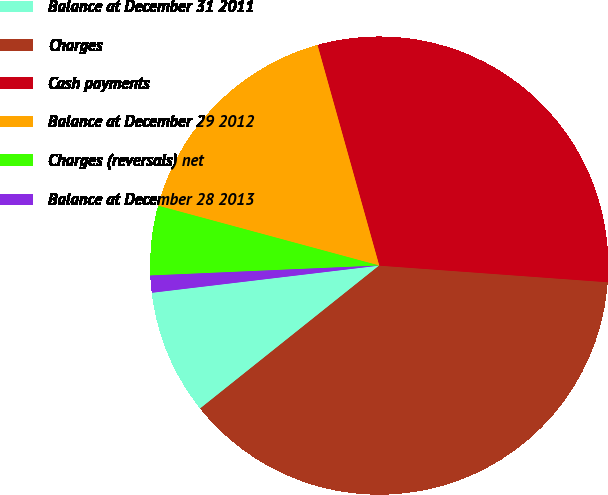Convert chart. <chart><loc_0><loc_0><loc_500><loc_500><pie_chart><fcel>Balance at December 31 2011<fcel>Charges<fcel>Cash payments<fcel>Balance at December 29 2012<fcel>Charges (reversals) net<fcel>Balance at December 28 2013<nl><fcel>8.83%<fcel>38.12%<fcel>30.5%<fcel>16.45%<fcel>4.9%<fcel>1.2%<nl></chart> 